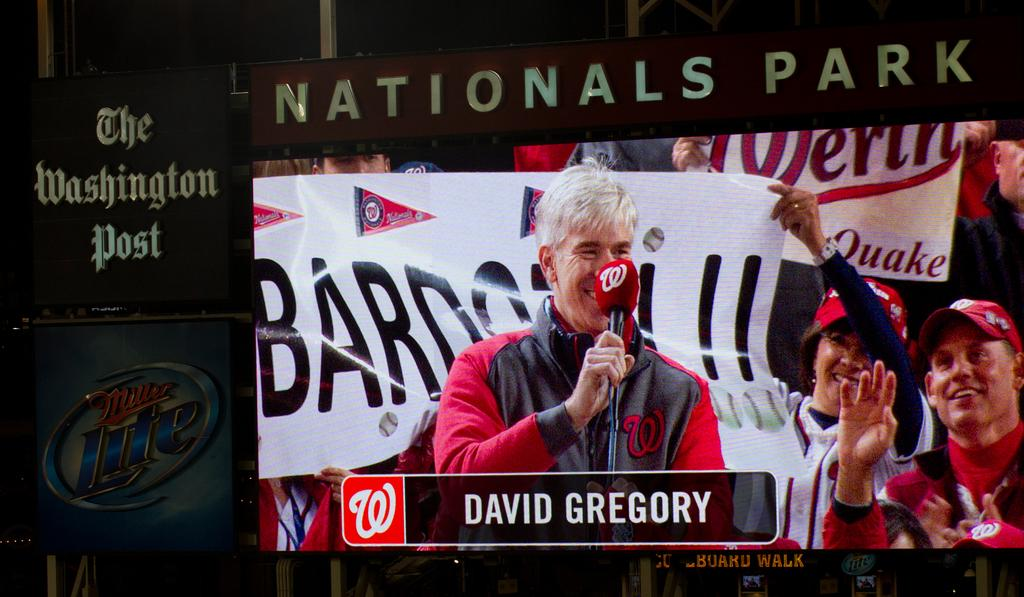What is the main object in the center of the image? There is a screen in the center of the image. What else can be seen in the image besides the screen? There are boards visible in the image. Where is the kitty hanging from a hook on the range in the image? There is no kitty, hook, or range present in the image. 